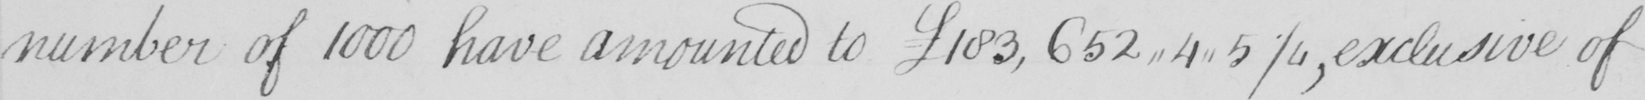What does this handwritten line say? number of 1000 have amounted to  £183,652,,4,,5 1/4 , exclusive of 